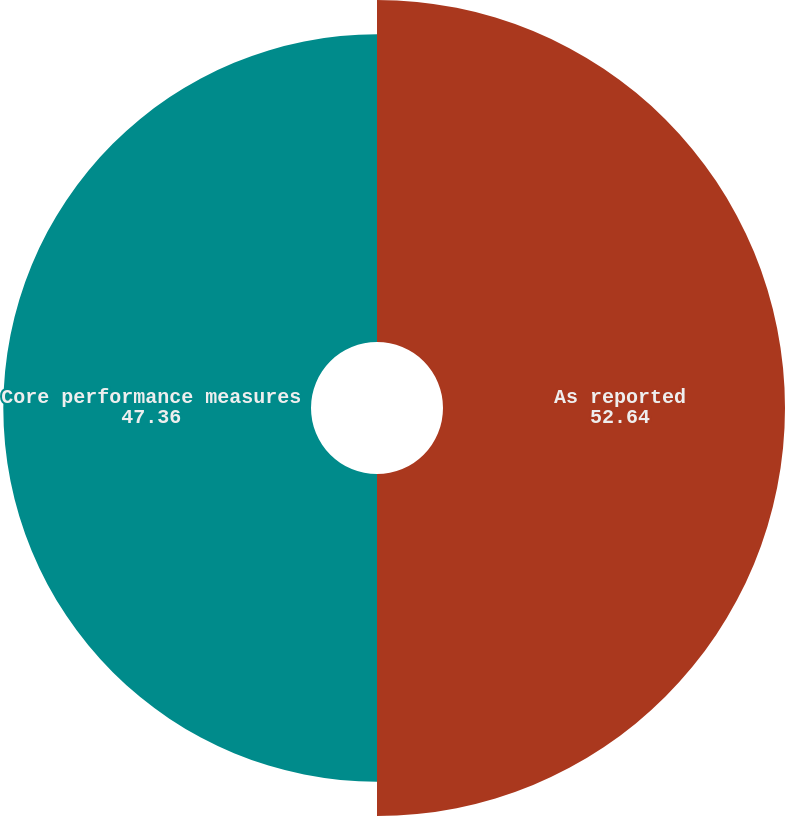Convert chart. <chart><loc_0><loc_0><loc_500><loc_500><pie_chart><fcel>As reported<fcel>Core performance measures<nl><fcel>52.64%<fcel>47.36%<nl></chart> 